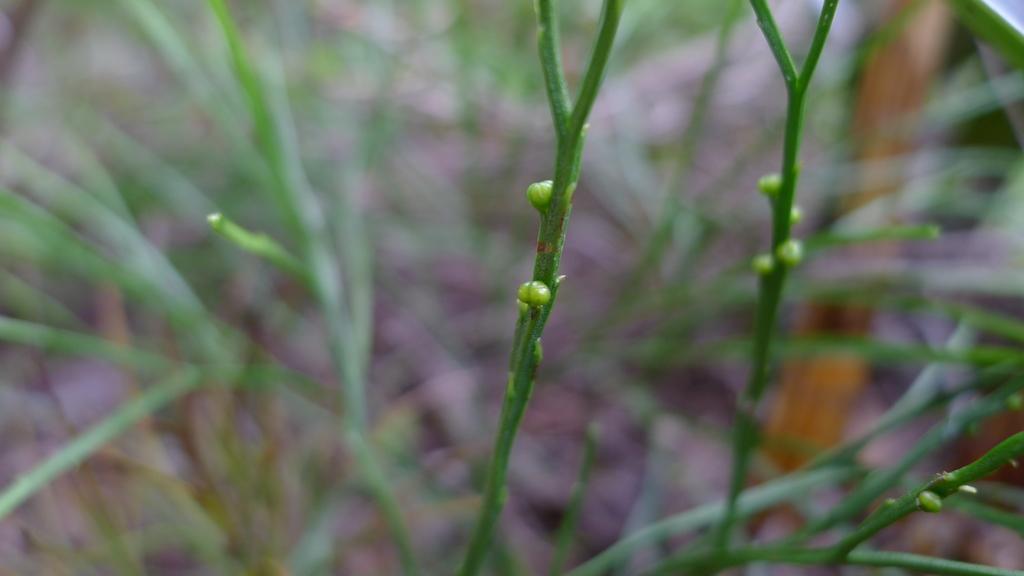Describe this image in one or two sentences. In this picture we can see buds and branches of a plant, there is a blurry background. 